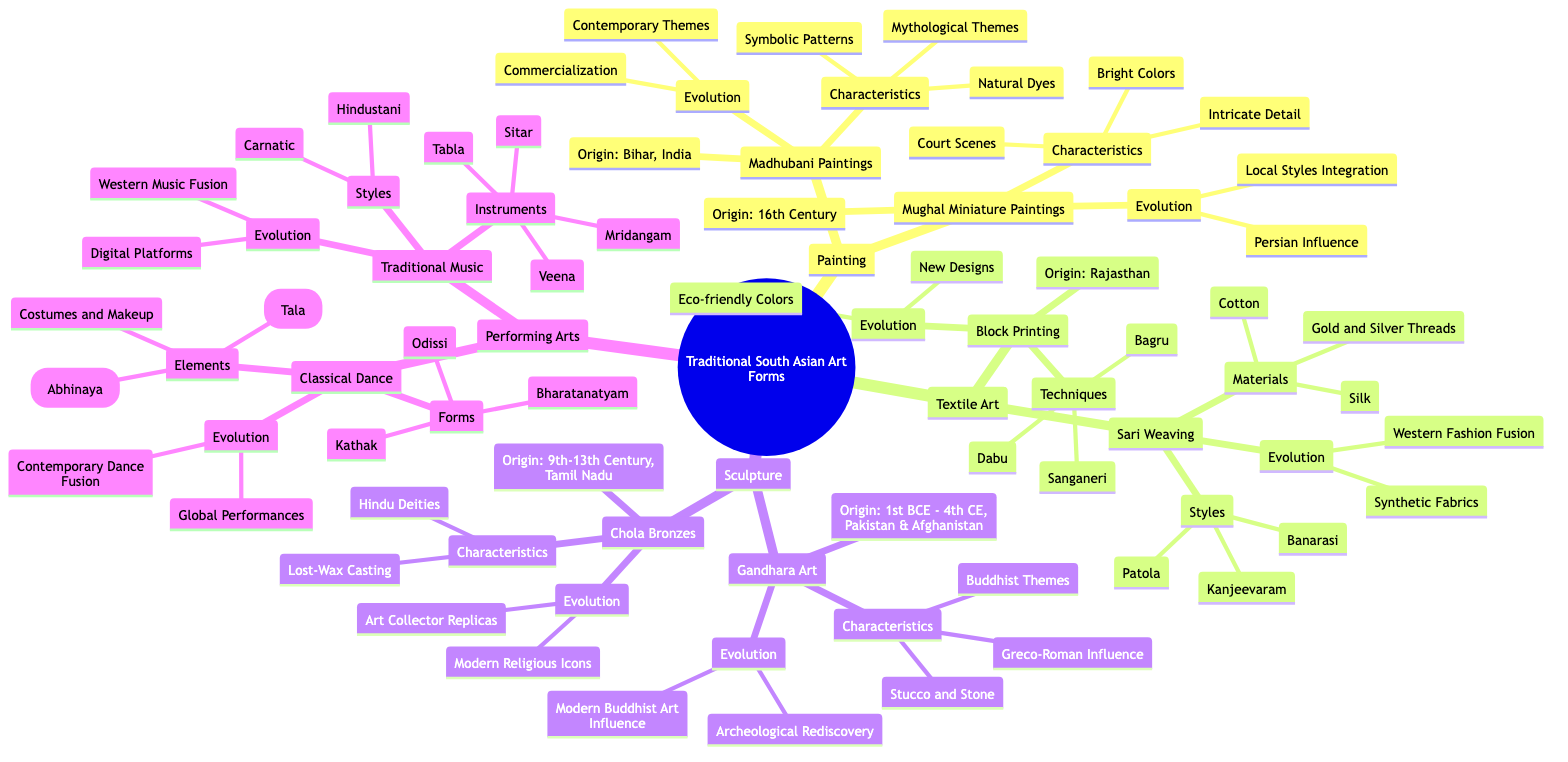What is the origin of Mughal Miniature Paintings? The origin of Mughal Miniature Paintings is specified in the diagram under the respective node, which states "16th Century" for this art form.
Answer: 16th Century Which two art forms have a salient characteristic of depicting deities? By looking at the characteristics listed under both Chola Bronzes and Gandhara Art, both emphasize on "Depiction of Hindu Deities" and "Buddhist Themes," highlighting spiritual representations in both.
Answer: Hindu Deities, Buddhist Themes How many styles of sari weaving are mentioned? The diagram shows a sub-node under Sari Weaving that lists three styles: Kanjeevaram, Banarasi, and Patola. To find the total, simply count these specific styles.
Answer: 3 What evolution aspect is shared between Madhubani Paintings and Sari Weaving? The evolution parts of Madhubani Paintings ("Commercialization for Modern Art Market") and Sari Weaving ("Introduction of Synthetic Fabrics") reflect the trend of adaptation to modern influences. Both involve incorporation of contemporary elements.
Answer: Commercialization, Synthetic Fabrics Which traditional music style is associated with South India? The diagram specifically lists "Carnatic" as one of the styles under Traditional Music, indicating its geographical association.
Answer: Carnatic What materials are used in the art of Sari Weaving? The materials used are clearly specified under the Sari Weaving node, which states "Silk, Cotton, Gold and Silver Threads". This directly answers the question regarding the materials used in this traditional textile art.
Answer: Silk, Cotton, Gold and Silver Threads How has the Mughal Miniature Painting style evolved? The evolution details mention two specific aspects: "Influence of Persian Art" and "Integration of Local Styles." To answer the question, one can state these two influences on the art form.
Answer: Influence of Persian Art, Integration of Local Styles Which performing arts form emphasizes expression as a key element? The node on Classical Dance cites "Expression (Abhinaya)" as one of the elements, clearly highlighting its importance within this performing arts category.
Answer: Expression (Abhinaya) What characteristic of Gandhara Art shows its unique historical influence? The feature "Greco-Roman Influence" listed explains the unique historical interaction and impact evident in Gandhara Art, showcasing its cross-cultural significance.
Answer: Greco-Roman Influence 